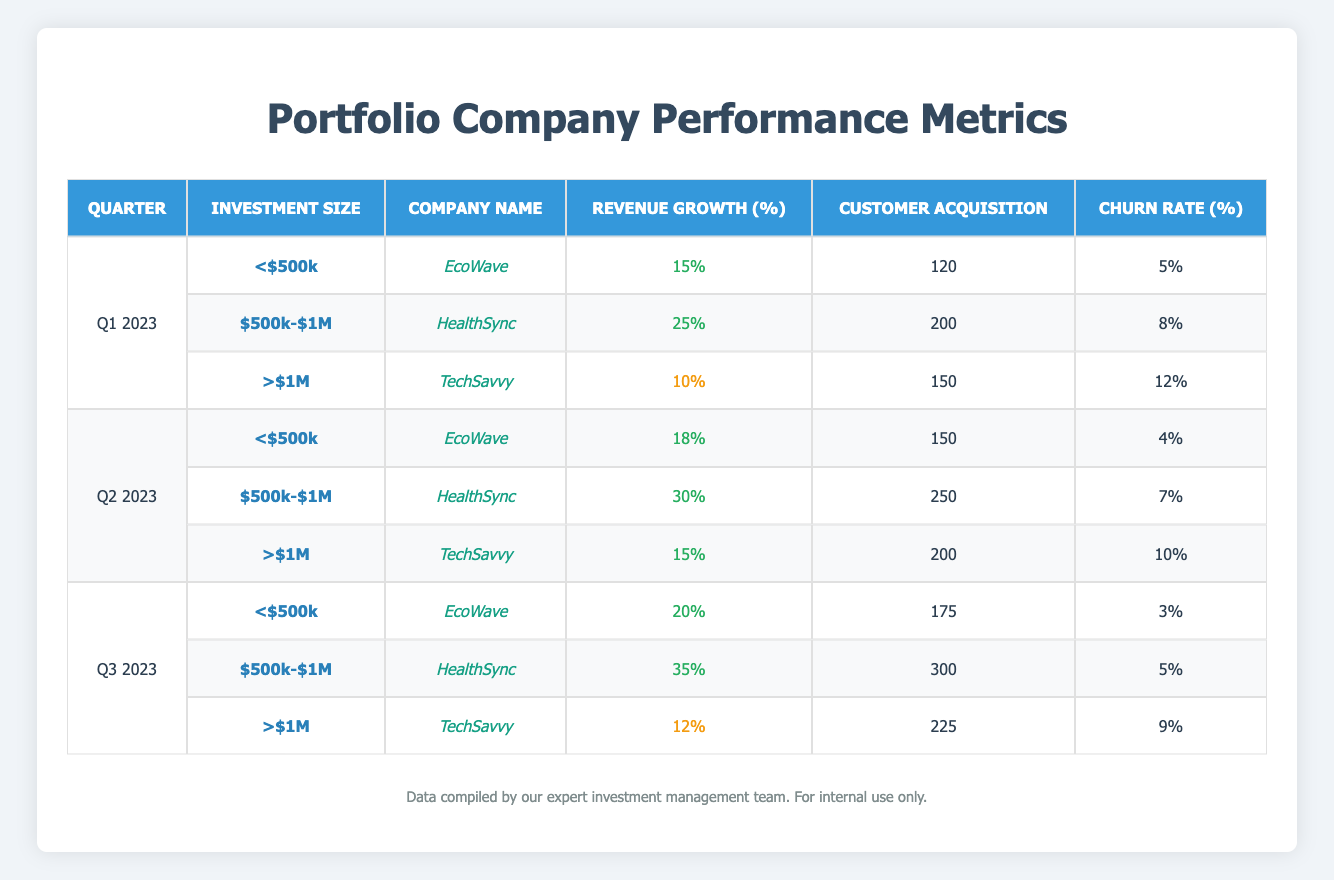What was the highest revenue growth percentage recorded in Q1 2023? In Q1 2023, the revenue growth percentages listed are 15% for EcoWave, 25% for HealthSync, and 10% for TechSavvy. The highest of these values is 25%, which belongs to HealthSync.
Answer: 25% Which company had the lowest churn rate in Q2 2023? In Q2 2023, the churn rates are 4% for EcoWave, 7% for HealthSync, and 10% for TechSavvy. The lowest among these is 4%, attributed to EcoWave.
Answer: EcoWave What is the average customer acquisition for companies with investment size "$500k-$1M"? For the investment size "$500k-$1M", the customer acquisition numbers are 200 for HealthSync in Q1 2023, 250 for HealthSync in Q2 2023, and 300 for HealthSync in Q3 2023. The average is calculated by summing these values (200 + 250 + 300 = 750) and dividing by the number of data points (3), which gives an average of 750/3 = 250.
Answer: 250 Did EcoWave show an increase in revenue growth from Q1 2023 to Q3 2023? EcoWave had a revenue growth of 15% in Q1 2023, 18% in Q2 2023, and 20% in Q3 2023. Since the values increased sequentially from 15% to 20%, the answer is yes.
Answer: Yes Which company had the maximum churn rate across all quarters? The churn rates for all companies across quarters are 5% (EcoWave) in Q1 2023, 8% (HealthSync) in Q1 2023, 12% (TechSavvy) in Q1 2023, 4% (EcoWave) in Q2 2023, 7% (HealthSync) in Q2 2023, 10% (TechSavvy) in Q2 2023, 3% (EcoWave) in Q3 2023, 5% (HealthSync) in Q3 2023, and 9% (TechSavvy) in Q3 2023. The maximum value is 12% from TechSavvy in Q1 2023.
Answer: TechSavvy What was the total customer acquisition for EcoWave across all quarters? The customer acquisition numbers for EcoWave are as follows: 120 in Q1 2023, 150 in Q2 2023, and 175 in Q3 2023. The total is calculated by adding these values (120 + 150 + 175 = 445).
Answer: 445 